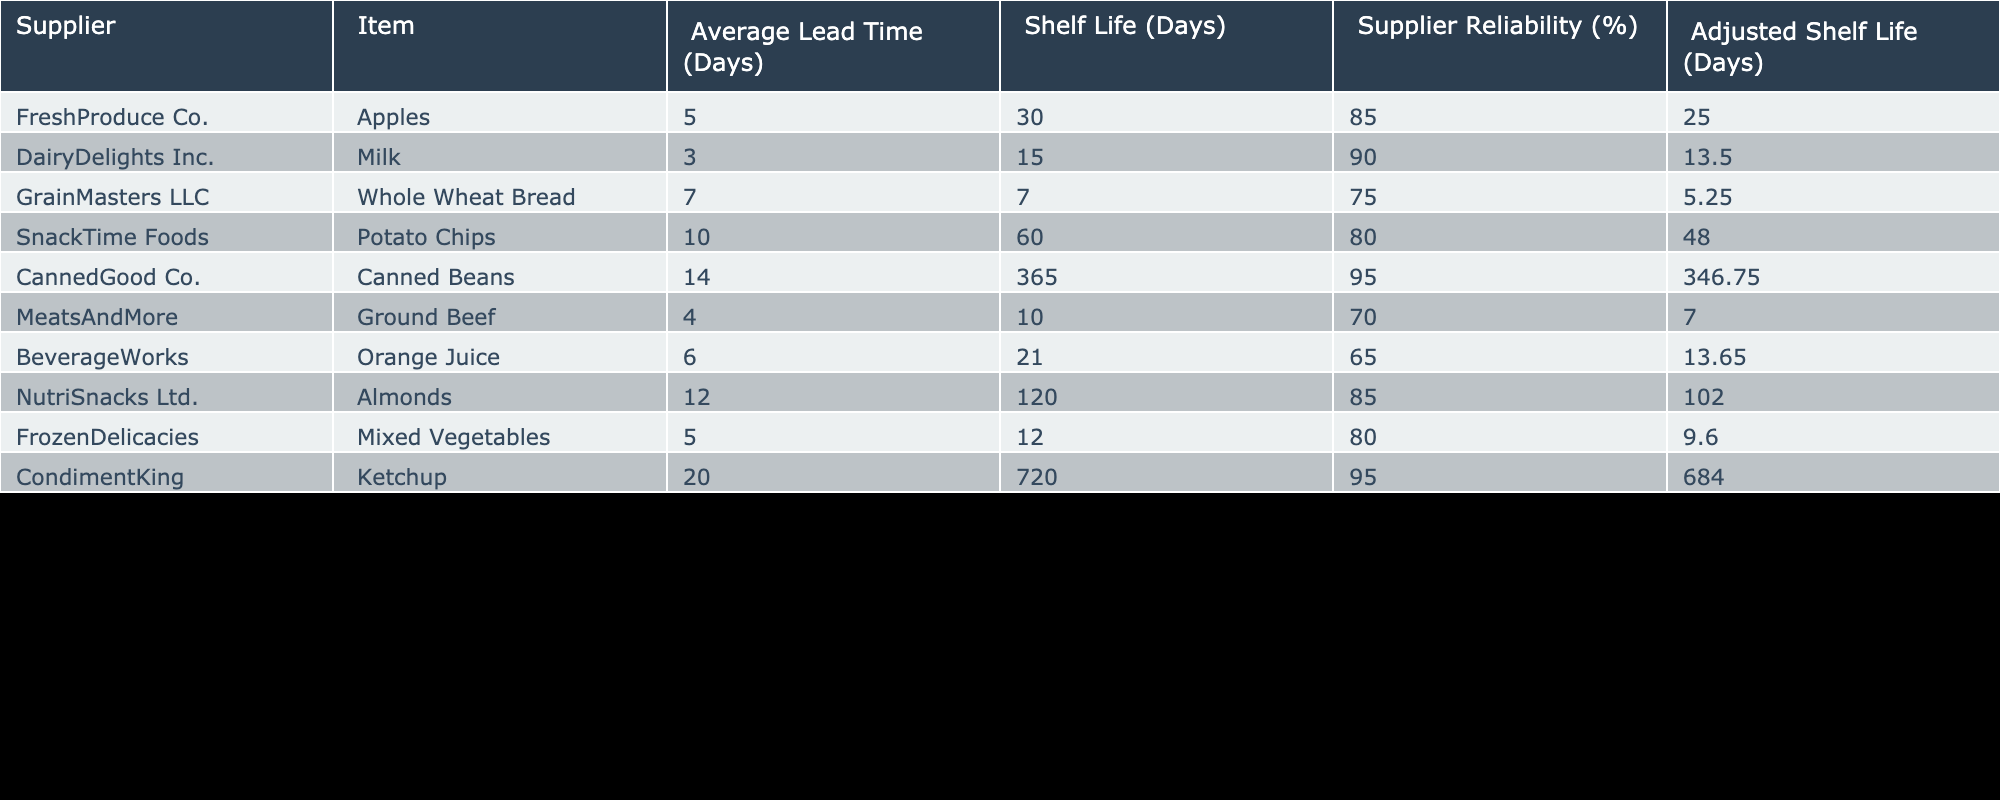What is the shelf life of potatoes chips? The shelf life for snack items like potato chips is directly provided in the table under the "Shelf Life (Days)" column. For Potato Chips, it's 60 days.
Answer: 60 days Which supplier has the highest supplier reliability? The "Supplier Reliability (%)" column shows the reliability percentages for each supplier. By comparing the values, we see that CannedGood Co. has the highest reliability at 95%.
Answer: CannedGood Co How much does the average shelf life of items from DairyDelights Inc. get adjusted? For DairyDelights Inc., the original shelf life is 15 days and adjusted shelf life is 13.5 days. The adjustment is calculated as the original shelf life minus the adjusted shelf life, which is 15 - 13.5 = 1.5 days.
Answer: 1.5 days If we combine the adjusted shelf lives of all items, what is the total? To find the total of adjusted shelf lives, we sum the adjusted values from the table: 25 + 13.5 + 5.25 + 48 + 346.75 + 7 + 13.65 + 102 + 9.6 + 684 = 1250.85 days.
Answer: 1250.85 days Is the adjusted shelf life of Almonds greater than that of Ground Beef? The adjusted shelf life of Almonds is 102 days and for Ground Beef it's 7 days. Since 102 > 7, the statement is true.
Answer: Yes What is the average shelf life of all items provided in the table? The average shelf life is calculated by summing all shelf lives (30 + 15 + 7 + 60 + 365 + 10 + 21 + 120 + 12 + 720) = 1290 days. There are 10 items, so the average is 1290 / 10 = 129 days.
Answer: 129 days Which item has the shortest shelf life, and what is its value? By examining the "Shelf Life (Days)" column, we find that Whole Wheat Bread has the shortest shelf life at 7 days.
Answer: 7 days If the shelf life of Canned Beans were adjusted by 10%, what would that value be? The current shelf life for Canned Beans is 365 days. Adjusting it by 10% means we take 10% of 365, which is 36.5 days. Therefore, the adjusted shelf life becomes 365 - 36.5 = 328.5 days.
Answer: 328.5 days Is the average lead time for items from FreshProduce Co. less than that of SnackTime Foods? The average lead time for FreshProduce Co. is 5 days and for SnackTime Foods is 10 days. Since 5 < 10, the statement is true.
Answer: Yes 